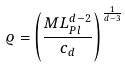Convert formula to latex. <formula><loc_0><loc_0><loc_500><loc_500>\varrho = \left ( \frac { M L _ { P l } ^ { d - 2 } } { c _ { d } } \right ) ^ { \frac { 1 } { d - 3 } }</formula> 